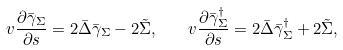Convert formula to latex. <formula><loc_0><loc_0><loc_500><loc_500>v \frac { \partial \bar { \gamma } _ { \Sigma } } { \partial s } = 2 \bar { \Delta } \bar { \gamma } _ { \Sigma } - 2 \tilde { \Sigma } , \quad v \frac { \partial \bar { \gamma } ^ { \dagger } _ { \Sigma } } { \partial s } = 2 \bar { \Delta } \bar { \gamma } _ { \Sigma } ^ { \dagger } + 2 \tilde { \Sigma } ,</formula> 